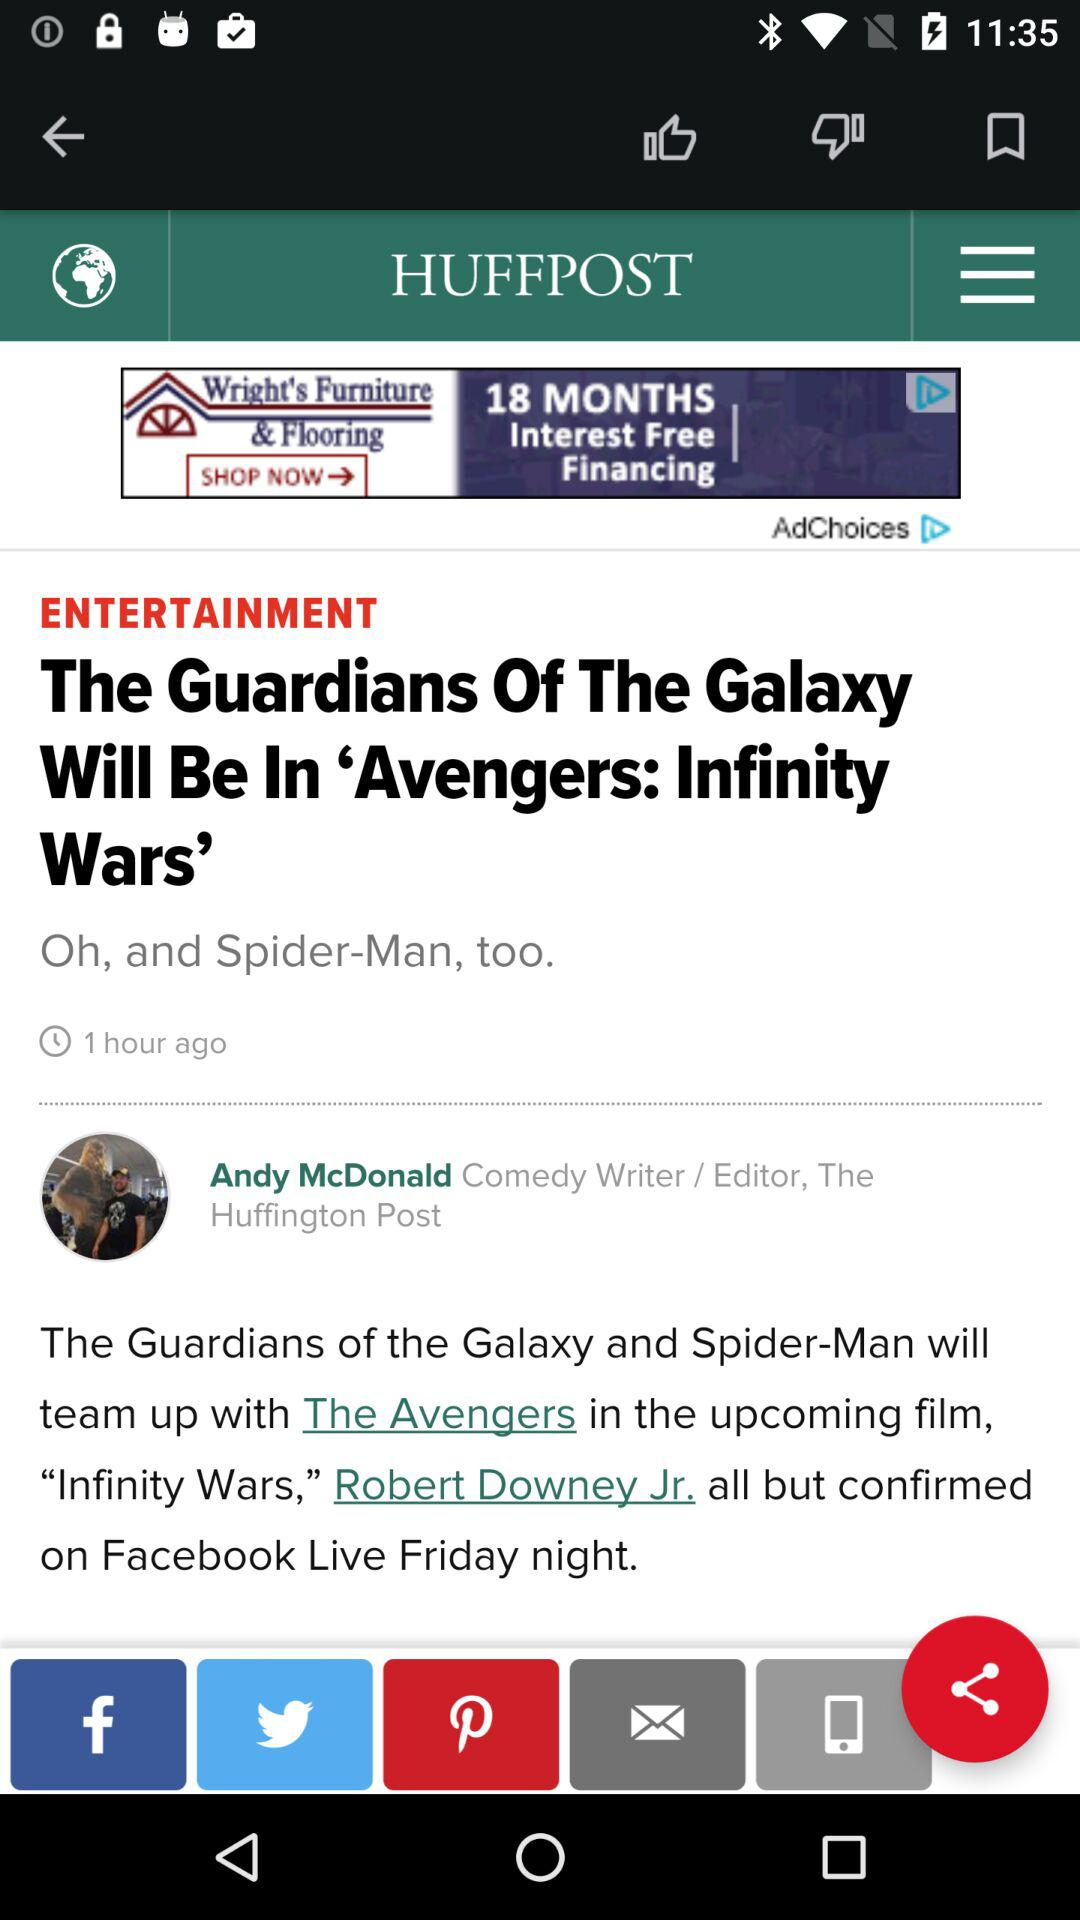When was the article posted? The article was posted 1 hour ago. 